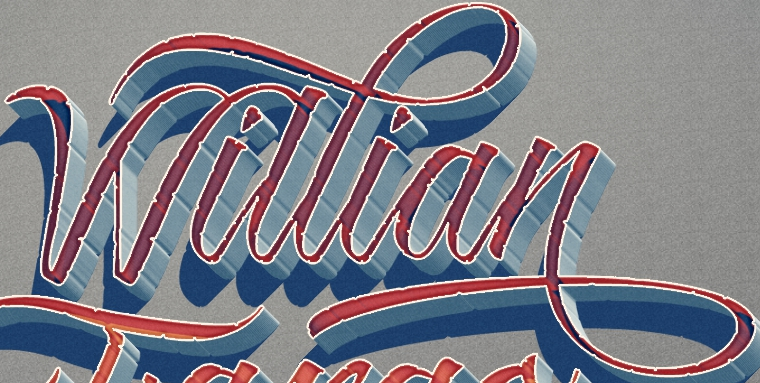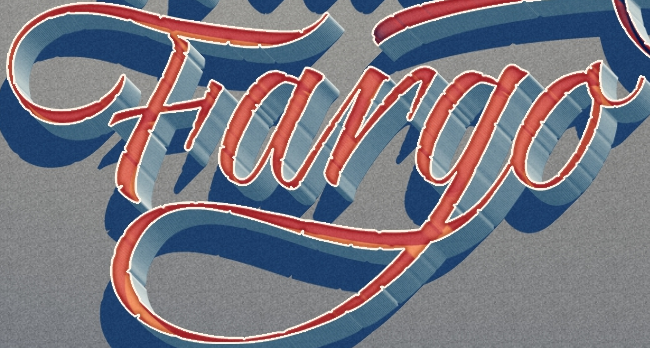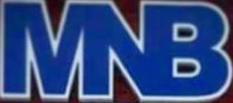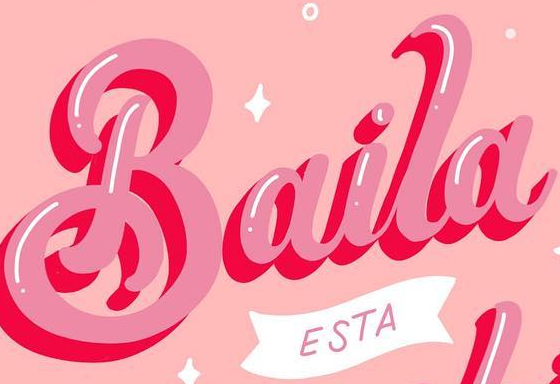What words are shown in these images in order, separated by a semicolon? Willian; Fargo; MNB; Baila 